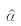<formula> <loc_0><loc_0><loc_500><loc_500>\hat { \alpha }</formula> 